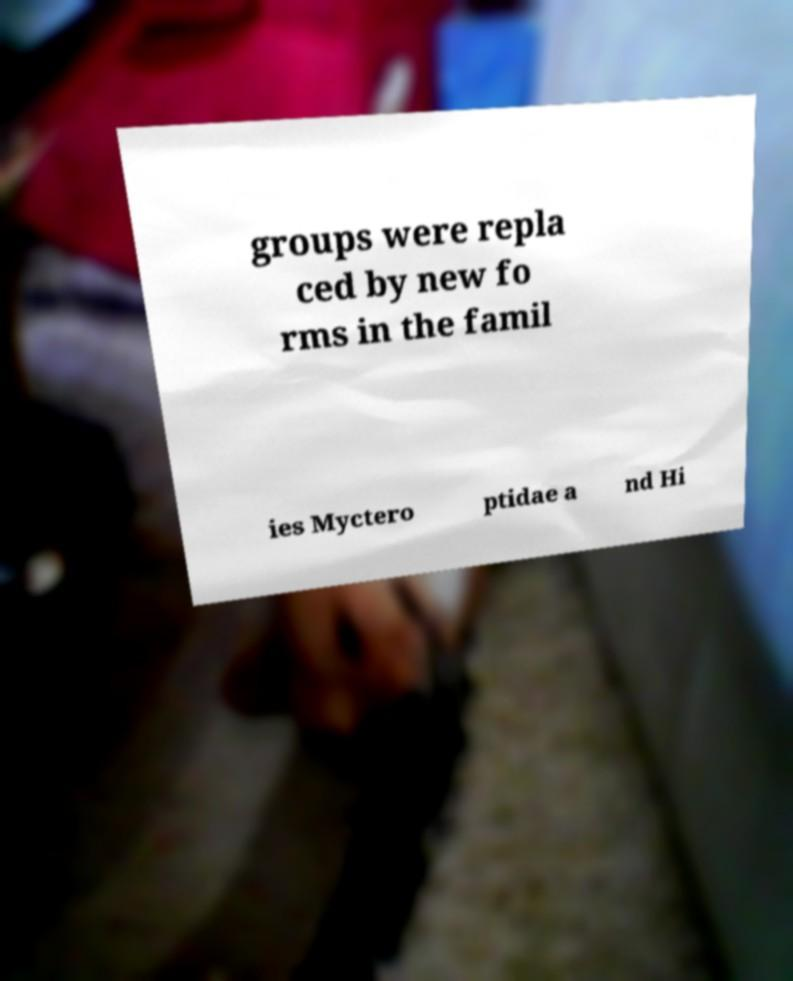What messages or text are displayed in this image? I need them in a readable, typed format. groups were repla ced by new fo rms in the famil ies Myctero ptidae a nd Hi 